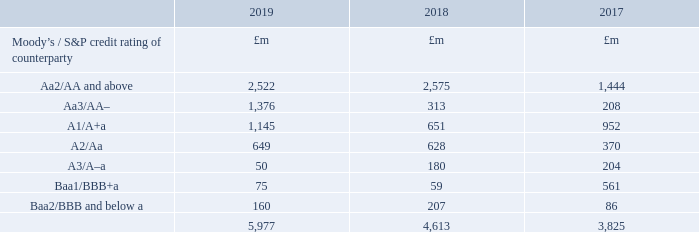The credit quality and credit concentration of cash equivalents, current asset investments and derivative financial assets are detailed in the tables below. Where the opinion of Moody’s and Standard & Poor’s (S&P) differ, the lower rating is used.
a We hold cash collateral of £638m (2017/18: £492m, 2016/17: £702m) in respect of derivative financial assets with certain counterparties.
The concentration of credit risk for our trading balances is provided in note 17, which analyses outstanding balances by customerfacing unit. Where multiple transactions are undertaken with a single financial counterparty or group of related counterparties, we enter into netting arrangements to reduce our exposure to credit risk by making use of standard International Swaps and Derivatives Association (ISDA) documentation.
We have also entered into credit support agreements with certain swap counterparties whereby, on a daily, weekly and monthly basis, the fair value position on notional £3,289m of long dated cross-currency swaps and interest rate swaps is collateralised. The related net cash inflow during the year was £129m (2017/18: outflow £220m, 2016/17: inflow £100m). The collateral paid and received is recognised within current asset investments and loans and other borrowings, respectively.
What is the cash collateral held by the company in 2019? £638m. What is the fair value position in 2019? £3,289m. What are the years that Moody’s / S&P credit rating of counterparty is provided? 2017, 2018, 2019. What is the change in the Aa2/AA and above from 2018 to 2019?
Answer scale should be: million. 2,522 - 2,575
Answer: -53. What is the average Aa3/AA– for 2017-2019?
Answer scale should be: million. (1,376 + 313 + 208) / 3
Answer: 632.33. In which year(s) is A1/A+a less than 1,000 million? Locate and analyze A1/A+a in row 5
Answer: 2018, 2017. 